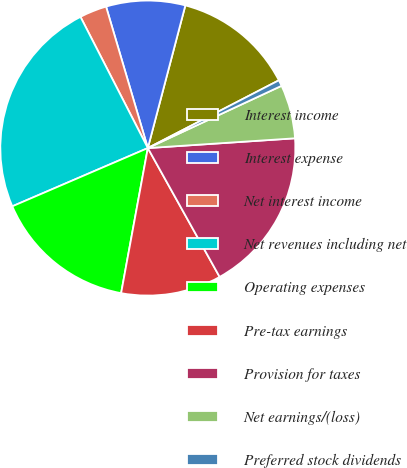<chart> <loc_0><loc_0><loc_500><loc_500><pie_chart><fcel>Interest income<fcel>Interest expense<fcel>Net interest income<fcel>Net revenues including net<fcel>Operating expenses<fcel>Pre-tax earnings<fcel>Provision for taxes<fcel>Net earnings/(loss)<fcel>Preferred stock dividends<nl><fcel>13.31%<fcel>8.66%<fcel>2.98%<fcel>23.91%<fcel>15.64%<fcel>10.99%<fcel>17.96%<fcel>5.88%<fcel>0.66%<nl></chart> 